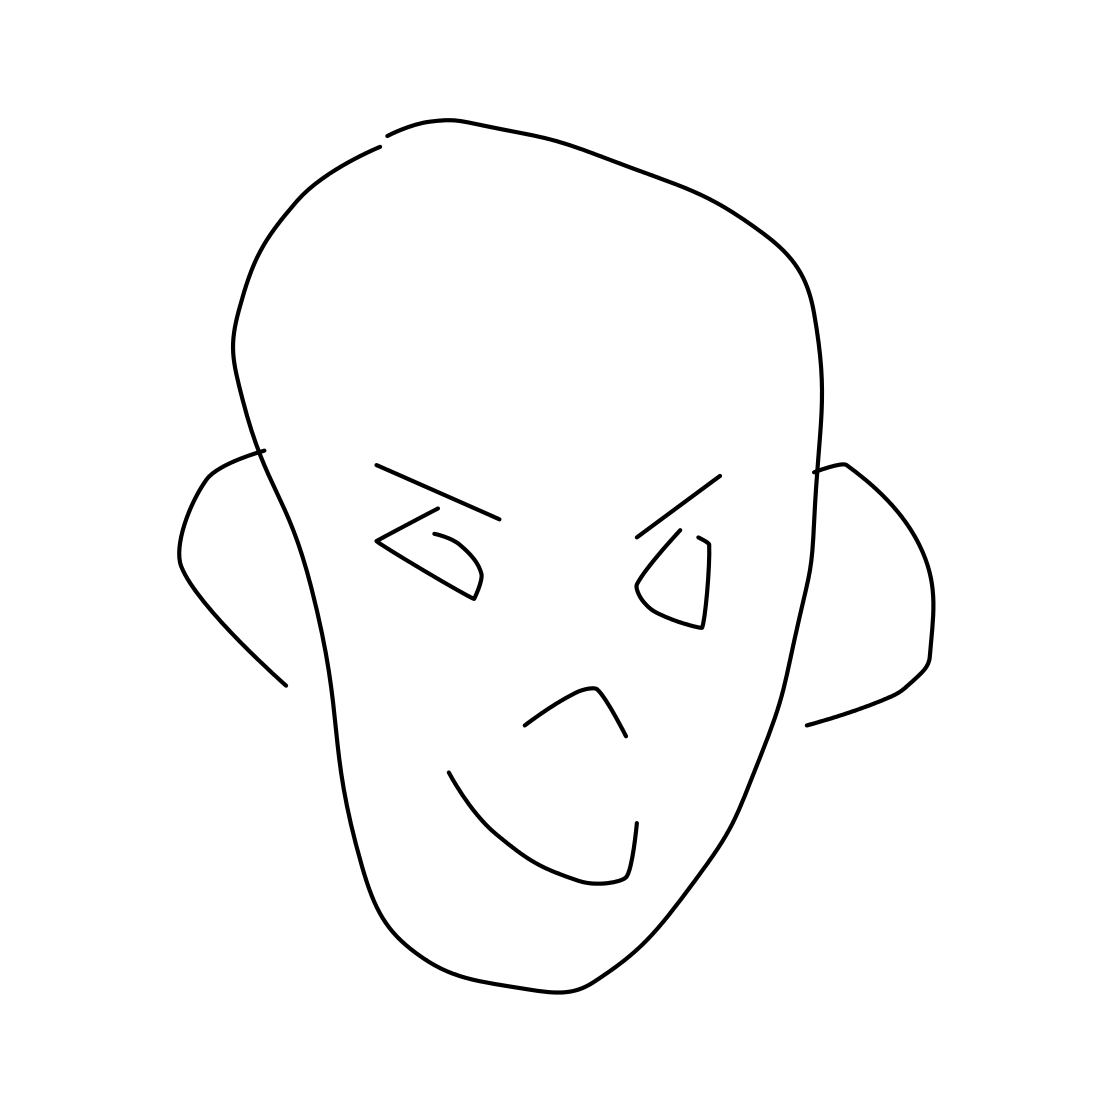What might be the purpose of creating such a drawing? Drawings like this could serve multiple purposes, such as being a conceptual sketch, an artistic expression of simplicity, or a visual exercise in conveying the essence of a subject with minimal detail. Could this style be inspired by any art movement? Yes, it seems to take inspiration from minimalism, an art movement where the work is stripped down to its most fundamental features, or from abstract art that emphasizes lines and geometric forms over realistic representation. 